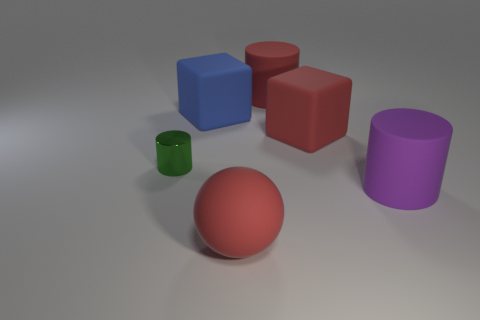There is a big matte cylinder that is behind the small shiny object; what color is it?
Your answer should be very brief. Red. There is a red cube that is made of the same material as the large sphere; what is its size?
Keep it short and to the point. Large. There is a red rubber object that is the same shape as the tiny shiny object; what is its size?
Your answer should be compact. Large. Is there a gray matte thing?
Make the answer very short. No. What number of things are matte blocks right of the large blue block or large red matte spheres?
Offer a terse response. 2. What color is the shiny cylinder behind the large purple rubber thing in front of the small thing?
Provide a succinct answer. Green. There is a green metal cylinder; what number of purple things are in front of it?
Make the answer very short. 1. The tiny shiny thing has what color?
Your answer should be very brief. Green. What number of big objects are either red matte spheres or green cubes?
Your response must be concise. 1. There is a large matte cube that is to the right of the matte sphere; does it have the same color as the matte thing behind the large blue cube?
Provide a succinct answer. Yes. 